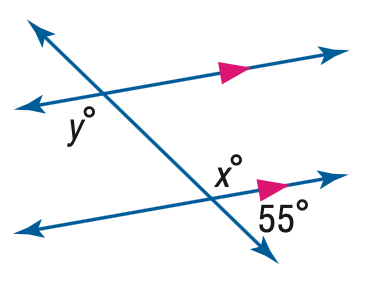Question: Find the value of the variable y in the figure.
Choices:
A. 55
B. 115
C. 125
D. 135
Answer with the letter. Answer: C 